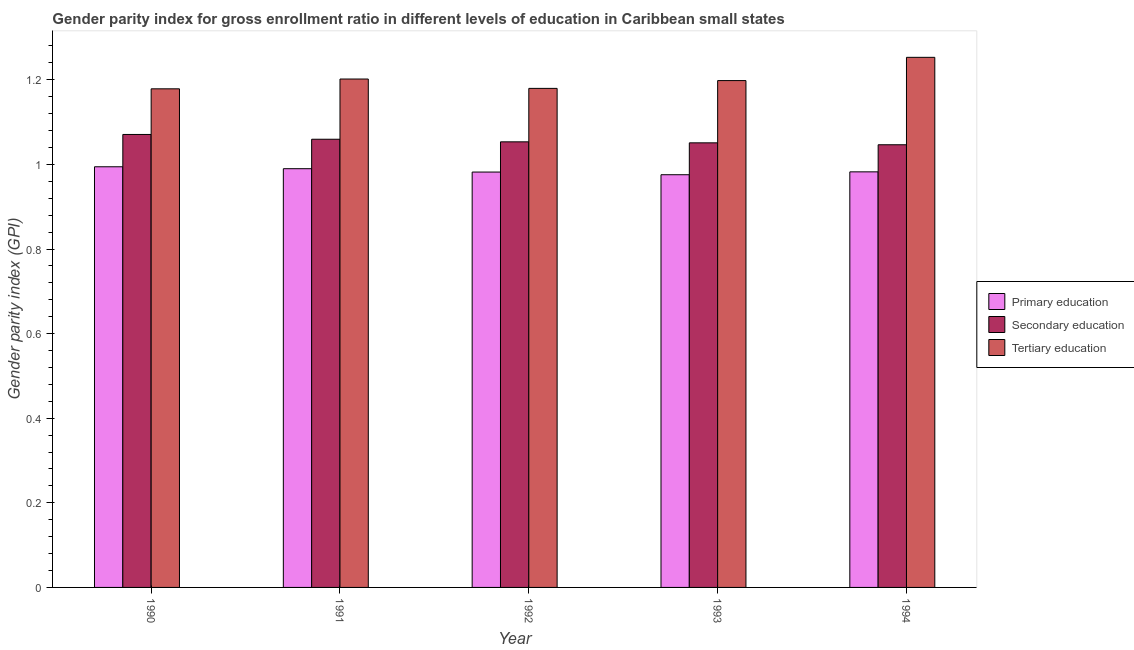How many different coloured bars are there?
Provide a succinct answer. 3. How many groups of bars are there?
Give a very brief answer. 5. Are the number of bars on each tick of the X-axis equal?
Offer a terse response. Yes. How many bars are there on the 5th tick from the right?
Provide a succinct answer. 3. What is the gender parity index in secondary education in 1991?
Ensure brevity in your answer.  1.06. Across all years, what is the maximum gender parity index in secondary education?
Give a very brief answer. 1.07. Across all years, what is the minimum gender parity index in secondary education?
Offer a very short reply. 1.05. In which year was the gender parity index in secondary education minimum?
Keep it short and to the point. 1994. What is the total gender parity index in tertiary education in the graph?
Your response must be concise. 6.01. What is the difference between the gender parity index in secondary education in 1993 and that in 1994?
Make the answer very short. 0. What is the difference between the gender parity index in secondary education in 1991 and the gender parity index in primary education in 1992?
Offer a terse response. 0.01. What is the average gender parity index in primary education per year?
Give a very brief answer. 0.98. What is the ratio of the gender parity index in primary education in 1991 to that in 1993?
Keep it short and to the point. 1.01. What is the difference between the highest and the second highest gender parity index in tertiary education?
Give a very brief answer. 0.05. What is the difference between the highest and the lowest gender parity index in tertiary education?
Give a very brief answer. 0.07. In how many years, is the gender parity index in secondary education greater than the average gender parity index in secondary education taken over all years?
Your response must be concise. 2. What does the 2nd bar from the left in 1990 represents?
Your answer should be very brief. Secondary education. Is it the case that in every year, the sum of the gender parity index in primary education and gender parity index in secondary education is greater than the gender parity index in tertiary education?
Provide a short and direct response. Yes. How many years are there in the graph?
Your response must be concise. 5. What is the difference between two consecutive major ticks on the Y-axis?
Keep it short and to the point. 0.2. Does the graph contain any zero values?
Offer a terse response. No. How many legend labels are there?
Offer a very short reply. 3. How are the legend labels stacked?
Provide a short and direct response. Vertical. What is the title of the graph?
Make the answer very short. Gender parity index for gross enrollment ratio in different levels of education in Caribbean small states. What is the label or title of the Y-axis?
Your response must be concise. Gender parity index (GPI). What is the Gender parity index (GPI) of Primary education in 1990?
Ensure brevity in your answer.  0.99. What is the Gender parity index (GPI) in Secondary education in 1990?
Ensure brevity in your answer.  1.07. What is the Gender parity index (GPI) of Tertiary education in 1990?
Your response must be concise. 1.18. What is the Gender parity index (GPI) of Primary education in 1991?
Offer a very short reply. 0.99. What is the Gender parity index (GPI) in Secondary education in 1991?
Keep it short and to the point. 1.06. What is the Gender parity index (GPI) in Tertiary education in 1991?
Offer a terse response. 1.2. What is the Gender parity index (GPI) of Primary education in 1992?
Your answer should be very brief. 0.98. What is the Gender parity index (GPI) of Secondary education in 1992?
Offer a terse response. 1.05. What is the Gender parity index (GPI) of Tertiary education in 1992?
Give a very brief answer. 1.18. What is the Gender parity index (GPI) of Primary education in 1993?
Offer a very short reply. 0.98. What is the Gender parity index (GPI) in Secondary education in 1993?
Your answer should be very brief. 1.05. What is the Gender parity index (GPI) of Tertiary education in 1993?
Your answer should be very brief. 1.2. What is the Gender parity index (GPI) in Primary education in 1994?
Give a very brief answer. 0.98. What is the Gender parity index (GPI) in Secondary education in 1994?
Your response must be concise. 1.05. What is the Gender parity index (GPI) of Tertiary education in 1994?
Ensure brevity in your answer.  1.25. Across all years, what is the maximum Gender parity index (GPI) in Primary education?
Your answer should be very brief. 0.99. Across all years, what is the maximum Gender parity index (GPI) of Secondary education?
Provide a succinct answer. 1.07. Across all years, what is the maximum Gender parity index (GPI) of Tertiary education?
Ensure brevity in your answer.  1.25. Across all years, what is the minimum Gender parity index (GPI) in Primary education?
Provide a short and direct response. 0.98. Across all years, what is the minimum Gender parity index (GPI) of Secondary education?
Your answer should be very brief. 1.05. Across all years, what is the minimum Gender parity index (GPI) of Tertiary education?
Your response must be concise. 1.18. What is the total Gender parity index (GPI) in Primary education in the graph?
Keep it short and to the point. 4.92. What is the total Gender parity index (GPI) of Secondary education in the graph?
Give a very brief answer. 5.28. What is the total Gender parity index (GPI) in Tertiary education in the graph?
Provide a succinct answer. 6.01. What is the difference between the Gender parity index (GPI) in Primary education in 1990 and that in 1991?
Your answer should be very brief. 0. What is the difference between the Gender parity index (GPI) in Secondary education in 1990 and that in 1991?
Make the answer very short. 0.01. What is the difference between the Gender parity index (GPI) in Tertiary education in 1990 and that in 1991?
Your answer should be compact. -0.02. What is the difference between the Gender parity index (GPI) in Primary education in 1990 and that in 1992?
Make the answer very short. 0.01. What is the difference between the Gender parity index (GPI) in Secondary education in 1990 and that in 1992?
Ensure brevity in your answer.  0.02. What is the difference between the Gender parity index (GPI) of Tertiary education in 1990 and that in 1992?
Provide a succinct answer. -0. What is the difference between the Gender parity index (GPI) of Primary education in 1990 and that in 1993?
Ensure brevity in your answer.  0.02. What is the difference between the Gender parity index (GPI) of Secondary education in 1990 and that in 1993?
Provide a succinct answer. 0.02. What is the difference between the Gender parity index (GPI) in Tertiary education in 1990 and that in 1993?
Your response must be concise. -0.02. What is the difference between the Gender parity index (GPI) of Primary education in 1990 and that in 1994?
Provide a succinct answer. 0.01. What is the difference between the Gender parity index (GPI) of Secondary education in 1990 and that in 1994?
Provide a succinct answer. 0.02. What is the difference between the Gender parity index (GPI) of Tertiary education in 1990 and that in 1994?
Provide a succinct answer. -0.07. What is the difference between the Gender parity index (GPI) of Primary education in 1991 and that in 1992?
Provide a short and direct response. 0.01. What is the difference between the Gender parity index (GPI) of Secondary education in 1991 and that in 1992?
Offer a very short reply. 0.01. What is the difference between the Gender parity index (GPI) of Tertiary education in 1991 and that in 1992?
Make the answer very short. 0.02. What is the difference between the Gender parity index (GPI) in Primary education in 1991 and that in 1993?
Ensure brevity in your answer.  0.01. What is the difference between the Gender parity index (GPI) of Secondary education in 1991 and that in 1993?
Make the answer very short. 0.01. What is the difference between the Gender parity index (GPI) of Tertiary education in 1991 and that in 1993?
Your answer should be compact. 0. What is the difference between the Gender parity index (GPI) of Primary education in 1991 and that in 1994?
Your response must be concise. 0.01. What is the difference between the Gender parity index (GPI) in Secondary education in 1991 and that in 1994?
Your response must be concise. 0.01. What is the difference between the Gender parity index (GPI) in Tertiary education in 1991 and that in 1994?
Make the answer very short. -0.05. What is the difference between the Gender parity index (GPI) in Primary education in 1992 and that in 1993?
Provide a succinct answer. 0.01. What is the difference between the Gender parity index (GPI) in Secondary education in 1992 and that in 1993?
Offer a very short reply. 0. What is the difference between the Gender parity index (GPI) of Tertiary education in 1992 and that in 1993?
Your response must be concise. -0.02. What is the difference between the Gender parity index (GPI) of Primary education in 1992 and that in 1994?
Ensure brevity in your answer.  -0. What is the difference between the Gender parity index (GPI) in Secondary education in 1992 and that in 1994?
Offer a very short reply. 0.01. What is the difference between the Gender parity index (GPI) in Tertiary education in 1992 and that in 1994?
Provide a short and direct response. -0.07. What is the difference between the Gender parity index (GPI) in Primary education in 1993 and that in 1994?
Offer a very short reply. -0.01. What is the difference between the Gender parity index (GPI) of Secondary education in 1993 and that in 1994?
Offer a terse response. 0. What is the difference between the Gender parity index (GPI) of Tertiary education in 1993 and that in 1994?
Your answer should be very brief. -0.06. What is the difference between the Gender parity index (GPI) of Primary education in 1990 and the Gender parity index (GPI) of Secondary education in 1991?
Your answer should be very brief. -0.07. What is the difference between the Gender parity index (GPI) in Primary education in 1990 and the Gender parity index (GPI) in Tertiary education in 1991?
Provide a succinct answer. -0.21. What is the difference between the Gender parity index (GPI) in Secondary education in 1990 and the Gender parity index (GPI) in Tertiary education in 1991?
Provide a succinct answer. -0.13. What is the difference between the Gender parity index (GPI) of Primary education in 1990 and the Gender parity index (GPI) of Secondary education in 1992?
Your response must be concise. -0.06. What is the difference between the Gender parity index (GPI) in Primary education in 1990 and the Gender parity index (GPI) in Tertiary education in 1992?
Give a very brief answer. -0.19. What is the difference between the Gender parity index (GPI) of Secondary education in 1990 and the Gender parity index (GPI) of Tertiary education in 1992?
Your answer should be compact. -0.11. What is the difference between the Gender parity index (GPI) of Primary education in 1990 and the Gender parity index (GPI) of Secondary education in 1993?
Give a very brief answer. -0.06. What is the difference between the Gender parity index (GPI) of Primary education in 1990 and the Gender parity index (GPI) of Tertiary education in 1993?
Provide a succinct answer. -0.2. What is the difference between the Gender parity index (GPI) in Secondary education in 1990 and the Gender parity index (GPI) in Tertiary education in 1993?
Ensure brevity in your answer.  -0.13. What is the difference between the Gender parity index (GPI) in Primary education in 1990 and the Gender parity index (GPI) in Secondary education in 1994?
Keep it short and to the point. -0.05. What is the difference between the Gender parity index (GPI) in Primary education in 1990 and the Gender parity index (GPI) in Tertiary education in 1994?
Ensure brevity in your answer.  -0.26. What is the difference between the Gender parity index (GPI) of Secondary education in 1990 and the Gender parity index (GPI) of Tertiary education in 1994?
Your response must be concise. -0.18. What is the difference between the Gender parity index (GPI) of Primary education in 1991 and the Gender parity index (GPI) of Secondary education in 1992?
Make the answer very short. -0.06. What is the difference between the Gender parity index (GPI) in Primary education in 1991 and the Gender parity index (GPI) in Tertiary education in 1992?
Your response must be concise. -0.19. What is the difference between the Gender parity index (GPI) of Secondary education in 1991 and the Gender parity index (GPI) of Tertiary education in 1992?
Keep it short and to the point. -0.12. What is the difference between the Gender parity index (GPI) of Primary education in 1991 and the Gender parity index (GPI) of Secondary education in 1993?
Your response must be concise. -0.06. What is the difference between the Gender parity index (GPI) of Primary education in 1991 and the Gender parity index (GPI) of Tertiary education in 1993?
Offer a very short reply. -0.21. What is the difference between the Gender parity index (GPI) in Secondary education in 1991 and the Gender parity index (GPI) in Tertiary education in 1993?
Keep it short and to the point. -0.14. What is the difference between the Gender parity index (GPI) of Primary education in 1991 and the Gender parity index (GPI) of Secondary education in 1994?
Offer a terse response. -0.06. What is the difference between the Gender parity index (GPI) of Primary education in 1991 and the Gender parity index (GPI) of Tertiary education in 1994?
Offer a terse response. -0.26. What is the difference between the Gender parity index (GPI) of Secondary education in 1991 and the Gender parity index (GPI) of Tertiary education in 1994?
Make the answer very short. -0.19. What is the difference between the Gender parity index (GPI) in Primary education in 1992 and the Gender parity index (GPI) in Secondary education in 1993?
Provide a succinct answer. -0.07. What is the difference between the Gender parity index (GPI) of Primary education in 1992 and the Gender parity index (GPI) of Tertiary education in 1993?
Provide a short and direct response. -0.22. What is the difference between the Gender parity index (GPI) in Secondary education in 1992 and the Gender parity index (GPI) in Tertiary education in 1993?
Ensure brevity in your answer.  -0.14. What is the difference between the Gender parity index (GPI) of Primary education in 1992 and the Gender parity index (GPI) of Secondary education in 1994?
Make the answer very short. -0.06. What is the difference between the Gender parity index (GPI) of Primary education in 1992 and the Gender parity index (GPI) of Tertiary education in 1994?
Your answer should be very brief. -0.27. What is the difference between the Gender parity index (GPI) in Secondary education in 1992 and the Gender parity index (GPI) in Tertiary education in 1994?
Provide a succinct answer. -0.2. What is the difference between the Gender parity index (GPI) of Primary education in 1993 and the Gender parity index (GPI) of Secondary education in 1994?
Ensure brevity in your answer.  -0.07. What is the difference between the Gender parity index (GPI) in Primary education in 1993 and the Gender parity index (GPI) in Tertiary education in 1994?
Your response must be concise. -0.28. What is the difference between the Gender parity index (GPI) in Secondary education in 1993 and the Gender parity index (GPI) in Tertiary education in 1994?
Offer a very short reply. -0.2. What is the average Gender parity index (GPI) of Primary education per year?
Your response must be concise. 0.98. What is the average Gender parity index (GPI) of Secondary education per year?
Offer a terse response. 1.06. What is the average Gender parity index (GPI) in Tertiary education per year?
Your response must be concise. 1.2. In the year 1990, what is the difference between the Gender parity index (GPI) in Primary education and Gender parity index (GPI) in Secondary education?
Keep it short and to the point. -0.08. In the year 1990, what is the difference between the Gender parity index (GPI) in Primary education and Gender parity index (GPI) in Tertiary education?
Give a very brief answer. -0.18. In the year 1990, what is the difference between the Gender parity index (GPI) of Secondary education and Gender parity index (GPI) of Tertiary education?
Your answer should be very brief. -0.11. In the year 1991, what is the difference between the Gender parity index (GPI) of Primary education and Gender parity index (GPI) of Secondary education?
Provide a short and direct response. -0.07. In the year 1991, what is the difference between the Gender parity index (GPI) of Primary education and Gender parity index (GPI) of Tertiary education?
Offer a very short reply. -0.21. In the year 1991, what is the difference between the Gender parity index (GPI) of Secondary education and Gender parity index (GPI) of Tertiary education?
Provide a succinct answer. -0.14. In the year 1992, what is the difference between the Gender parity index (GPI) in Primary education and Gender parity index (GPI) in Secondary education?
Offer a very short reply. -0.07. In the year 1992, what is the difference between the Gender parity index (GPI) in Primary education and Gender parity index (GPI) in Tertiary education?
Keep it short and to the point. -0.2. In the year 1992, what is the difference between the Gender parity index (GPI) in Secondary education and Gender parity index (GPI) in Tertiary education?
Keep it short and to the point. -0.13. In the year 1993, what is the difference between the Gender parity index (GPI) in Primary education and Gender parity index (GPI) in Secondary education?
Ensure brevity in your answer.  -0.08. In the year 1993, what is the difference between the Gender parity index (GPI) in Primary education and Gender parity index (GPI) in Tertiary education?
Your answer should be compact. -0.22. In the year 1993, what is the difference between the Gender parity index (GPI) of Secondary education and Gender parity index (GPI) of Tertiary education?
Your answer should be very brief. -0.15. In the year 1994, what is the difference between the Gender parity index (GPI) of Primary education and Gender parity index (GPI) of Secondary education?
Offer a very short reply. -0.06. In the year 1994, what is the difference between the Gender parity index (GPI) in Primary education and Gender parity index (GPI) in Tertiary education?
Give a very brief answer. -0.27. In the year 1994, what is the difference between the Gender parity index (GPI) of Secondary education and Gender parity index (GPI) of Tertiary education?
Offer a very short reply. -0.21. What is the ratio of the Gender parity index (GPI) of Secondary education in 1990 to that in 1991?
Offer a very short reply. 1.01. What is the ratio of the Gender parity index (GPI) of Tertiary education in 1990 to that in 1991?
Your answer should be compact. 0.98. What is the ratio of the Gender parity index (GPI) of Primary education in 1990 to that in 1992?
Offer a terse response. 1.01. What is the ratio of the Gender parity index (GPI) in Secondary education in 1990 to that in 1992?
Provide a short and direct response. 1.02. What is the ratio of the Gender parity index (GPI) in Primary education in 1990 to that in 1993?
Your answer should be compact. 1.02. What is the ratio of the Gender parity index (GPI) in Secondary education in 1990 to that in 1993?
Your answer should be very brief. 1.02. What is the ratio of the Gender parity index (GPI) in Tertiary education in 1990 to that in 1993?
Your answer should be compact. 0.98. What is the ratio of the Gender parity index (GPI) of Primary education in 1990 to that in 1994?
Keep it short and to the point. 1.01. What is the ratio of the Gender parity index (GPI) of Secondary education in 1990 to that in 1994?
Your answer should be very brief. 1.02. What is the ratio of the Gender parity index (GPI) in Tertiary education in 1990 to that in 1994?
Your answer should be compact. 0.94. What is the ratio of the Gender parity index (GPI) in Tertiary education in 1991 to that in 1992?
Give a very brief answer. 1.02. What is the ratio of the Gender parity index (GPI) of Primary education in 1991 to that in 1993?
Your response must be concise. 1.01. What is the ratio of the Gender parity index (GPI) in Primary education in 1991 to that in 1994?
Offer a terse response. 1.01. What is the ratio of the Gender parity index (GPI) of Secondary education in 1991 to that in 1994?
Give a very brief answer. 1.01. What is the ratio of the Gender parity index (GPI) in Tertiary education in 1991 to that in 1994?
Give a very brief answer. 0.96. What is the ratio of the Gender parity index (GPI) of Primary education in 1992 to that in 1993?
Keep it short and to the point. 1.01. What is the ratio of the Gender parity index (GPI) of Secondary education in 1992 to that in 1993?
Ensure brevity in your answer.  1. What is the ratio of the Gender parity index (GPI) of Tertiary education in 1992 to that in 1993?
Offer a terse response. 0.98. What is the ratio of the Gender parity index (GPI) in Primary education in 1992 to that in 1994?
Provide a succinct answer. 1. What is the ratio of the Gender parity index (GPI) in Secondary education in 1992 to that in 1994?
Provide a succinct answer. 1.01. What is the ratio of the Gender parity index (GPI) in Tertiary education in 1992 to that in 1994?
Provide a succinct answer. 0.94. What is the ratio of the Gender parity index (GPI) in Tertiary education in 1993 to that in 1994?
Provide a succinct answer. 0.96. What is the difference between the highest and the second highest Gender parity index (GPI) in Primary education?
Give a very brief answer. 0. What is the difference between the highest and the second highest Gender parity index (GPI) in Secondary education?
Make the answer very short. 0.01. What is the difference between the highest and the second highest Gender parity index (GPI) of Tertiary education?
Give a very brief answer. 0.05. What is the difference between the highest and the lowest Gender parity index (GPI) of Primary education?
Keep it short and to the point. 0.02. What is the difference between the highest and the lowest Gender parity index (GPI) in Secondary education?
Provide a succinct answer. 0.02. What is the difference between the highest and the lowest Gender parity index (GPI) of Tertiary education?
Ensure brevity in your answer.  0.07. 